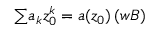<formula> <loc_0><loc_0><loc_500><loc_500>{ \sum } a _ { k } z _ { 0 } ^ { k } = a ( z _ { 0 } ) \, ( { w B } )</formula> 